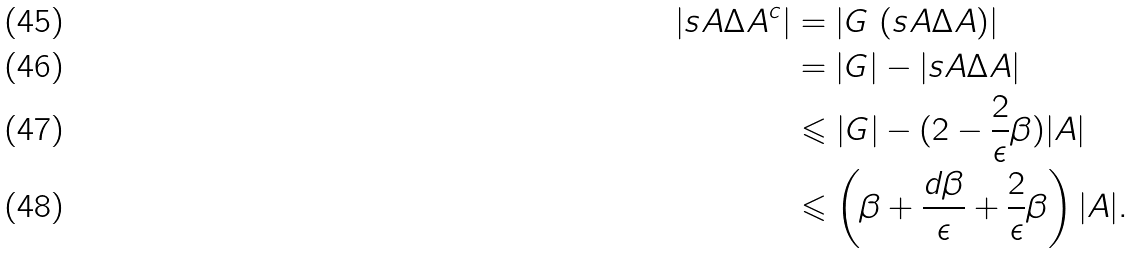Convert formula to latex. <formula><loc_0><loc_0><loc_500><loc_500>| s A \Delta A ^ { c } | & = | G \ ( s A \Delta A ) | \\ & = | G | - | s A \Delta A | \\ & \leqslant | G | - ( 2 - \frac { 2 } { \epsilon } \beta ) | A | \\ & \leqslant \left ( \beta + \frac { d \beta } { \epsilon } + \frac { 2 } { \epsilon } \beta \right ) | A | .</formula> 